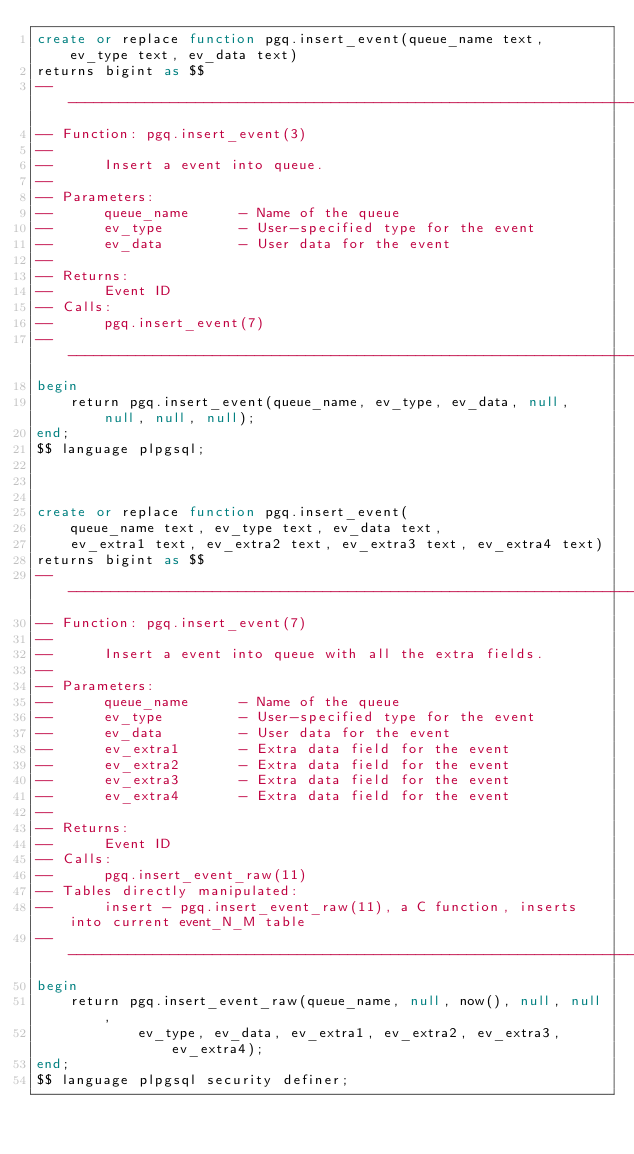Convert code to text. <code><loc_0><loc_0><loc_500><loc_500><_SQL_>create or replace function pgq.insert_event(queue_name text, ev_type text, ev_data text)
returns bigint as $$
-- ----------------------------------------------------------------------
-- Function: pgq.insert_event(3)
--
--      Insert a event into queue.
--
-- Parameters:
--      queue_name      - Name of the queue
--      ev_type         - User-specified type for the event
--      ev_data         - User data for the event
--
-- Returns:
--      Event ID
-- Calls:
--      pgq.insert_event(7)
-- ----------------------------------------------------------------------
begin
    return pgq.insert_event(queue_name, ev_type, ev_data, null, null, null, null);
end;
$$ language plpgsql;



create or replace function pgq.insert_event(
    queue_name text, ev_type text, ev_data text,
    ev_extra1 text, ev_extra2 text, ev_extra3 text, ev_extra4 text)
returns bigint as $$
-- ----------------------------------------------------------------------
-- Function: pgq.insert_event(7)
--
--      Insert a event into queue with all the extra fields.
--
-- Parameters:
--      queue_name      - Name of the queue
--      ev_type         - User-specified type for the event
--      ev_data         - User data for the event
--      ev_extra1       - Extra data field for the event
--      ev_extra2       - Extra data field for the event
--      ev_extra3       - Extra data field for the event
--      ev_extra4       - Extra data field for the event
--
-- Returns:
--      Event ID
-- Calls:
--      pgq.insert_event_raw(11)
-- Tables directly manipulated:
--      insert - pgq.insert_event_raw(11), a C function, inserts into current event_N_M table
-- ----------------------------------------------------------------------
begin
    return pgq.insert_event_raw(queue_name, null, now(), null, null,
            ev_type, ev_data, ev_extra1, ev_extra2, ev_extra3, ev_extra4);
end;
$$ language plpgsql security definer;

</code> 